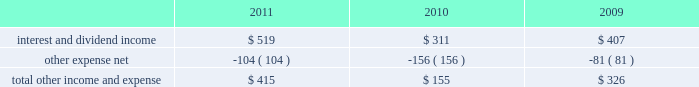R&d expense increased 36% ( 36 % ) during 2011 compared to 2010 , it declined slightly as a percentage of net sales , due to the 66% ( 66 % ) year-over-year growth in the company 2019s net sales during 2011 .
R&d expense increased 34% ( 34 % ) or $ 449 million to $ 1.8 billion in 2010 compared to 2009 .
This increase was due primarily to an increase in headcount and related expenses in the current year to support expanded r&d activities .
Also contributing to this increase in r&d expense in 2010 was the capitalization in 2009 of software development costs of $ 71 million related to mac os x snow leopard .
Although total r&d expense increased 34% ( 34 % ) during 2010 , it declined as a percentage of net sales given the 52% ( 52 % ) year-over-year increase in net sales in the company continues to believe that focused investments in r&d are critical to its future growth and competitive position in the marketplace and are directly related to timely development of new and enhanced products that are central to the company 2019s core business strategy .
As such , the company expects to make further investments in r&d to remain competitive .
Selling , general and administrative expense ( 201csg&a 201d ) sg&a expense increased $ 2.1 billion or 38% ( 38 % ) to $ 7.6 billion during 2011 compared to 2010 .
This increase was due primarily to the company 2019s continued expansion of its retail segment , increased headcount and related costs , higher spending on professional services and marketing and advertising programs , and increased variable costs associated with the overall growth of the company 2019s net sales .
Sg&a expense increased $ 1.4 billion or 33% ( 33 % ) to $ 5.5 billion in 2010 compared to 2009 .
This increase was due primarily to the company 2019s continued expansion of its retail segment , higher spending on marketing and advertising programs , increased share-based compensation expenses and variable costs associated with the overall growth of the company 2019s net sales .
Other income and expense other income and expense for the three years ended september 24 , 2011 , are as follows ( in millions ) : .
Total other income and expense increased $ 260 million or 168% ( 168 % ) to $ 415 million during 2011 compared to $ 155 million and $ 326 million in 2010 and 2009 , respectively .
The year-over-year increase in other income and expense during 2011 was due primarily to higher interest income and net realized gains on sales of marketable securities .
The overall decrease in other income and expense in 2010 compared to 2009 was attributable to the significant declines in interest rates on a year-over-year basis , partially offset by the company 2019s higher cash , cash equivalents and marketable securities balances .
Additionally the company incurred higher premium expenses on its foreign exchange option contracts , which further reduced the total other income and expense .
The weighted average interest rate earned by the company on its cash , cash equivalents and marketable securities was 0.77% ( 0.77 % ) , 0.75% ( 0.75 % ) and 1.43% ( 1.43 % ) during 2011 , 2010 and 2009 , respectively .
During 2011 , 2010 and 2009 , the company had no debt outstanding and accordingly did not incur any related interest expense .
Provision for income taxes the company 2019s effective tax rates were approximately 24.2% ( 24.2 % ) , 24.4% ( 24.4 % ) and 31.8% ( 31.8 % ) for 2011 , 2010 and 2009 , respectively .
The company 2019s effective rates for these periods differ from the statutory federal income tax rate of .
Interest and dividend income was what percent of total other income in 2010? 
Computations: (311 / 155)
Answer: 2.00645. 